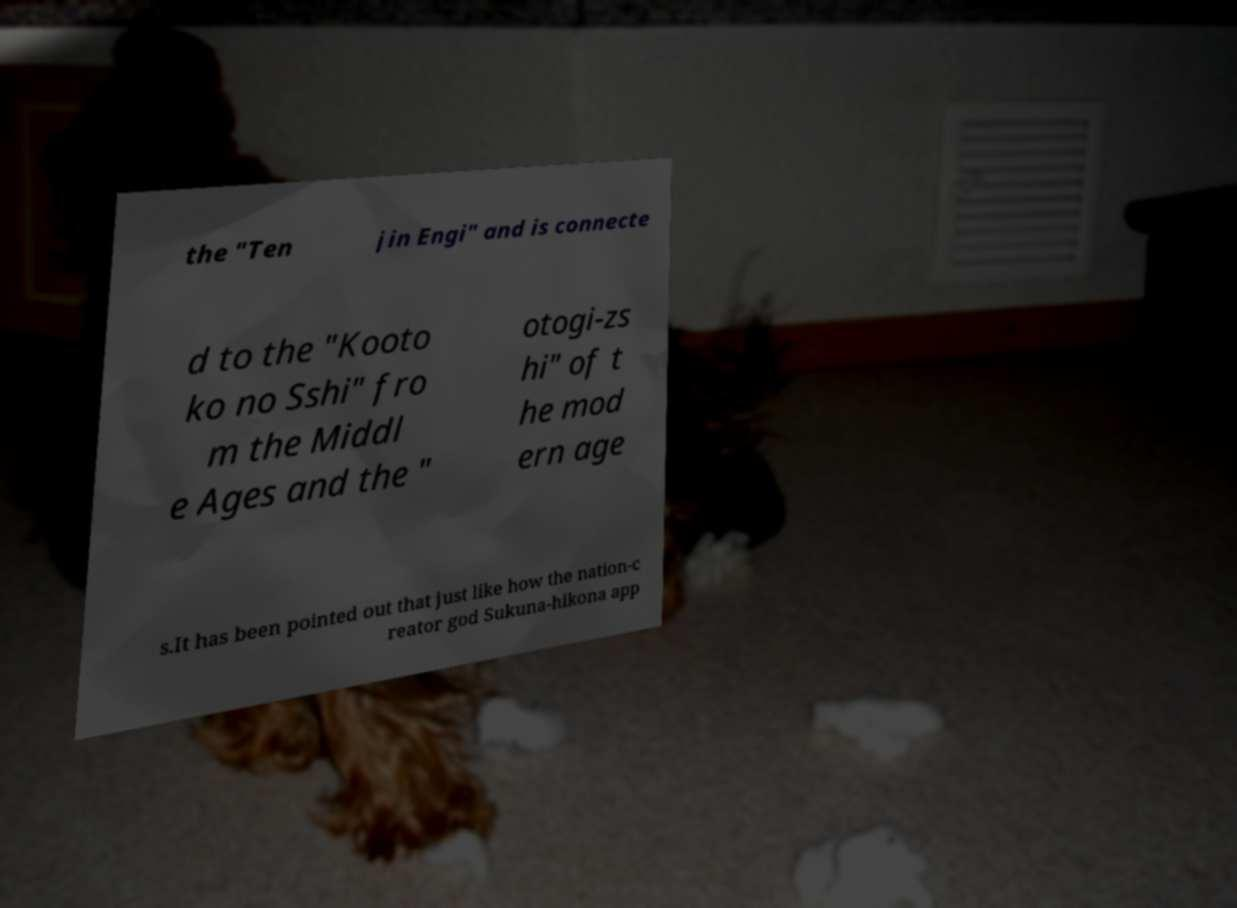I need the written content from this picture converted into text. Can you do that? the "Ten jin Engi" and is connecte d to the "Kooto ko no Sshi" fro m the Middl e Ages and the " otogi-zs hi" of t he mod ern age s.It has been pointed out that just like how the nation-c reator god Sukuna-hikona app 